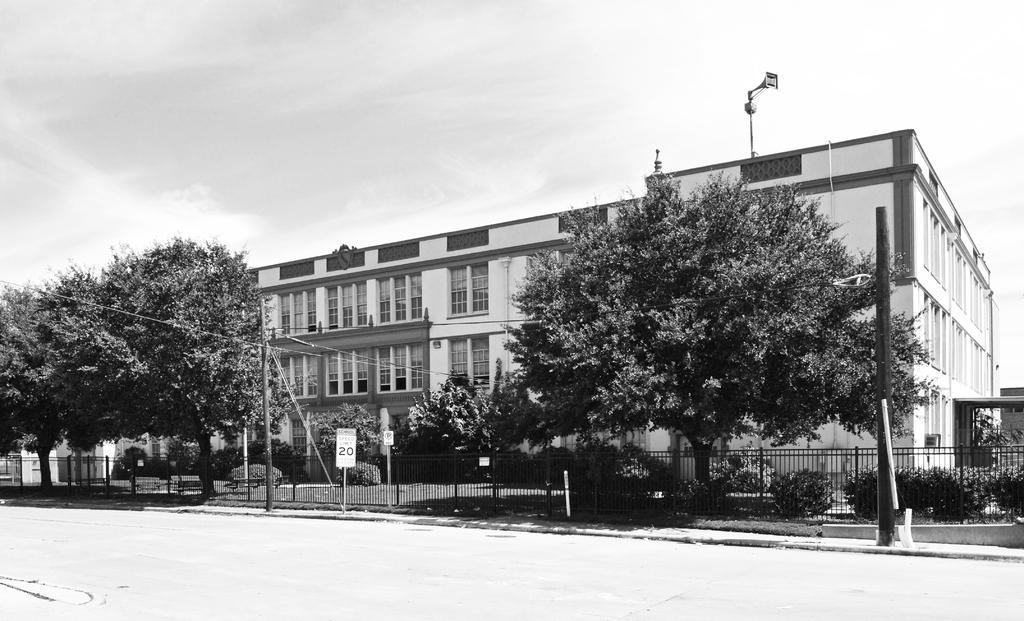Describe this image in one or two sentences. In this image we can see a building. In front of the building we can see a group of trees, plants, grass, fencing and poles with boards. At the top we can see the sky. 